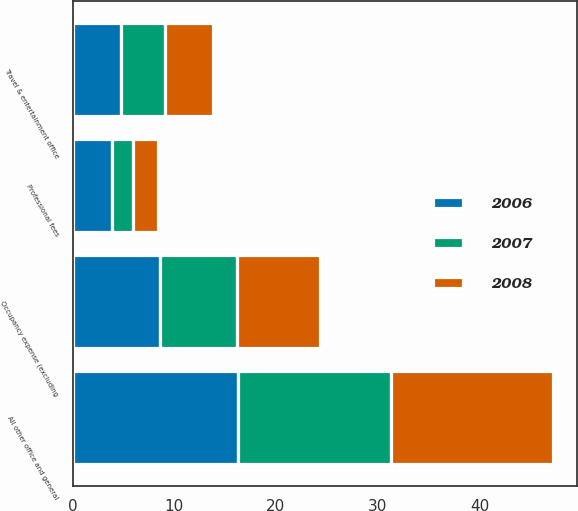<chart> <loc_0><loc_0><loc_500><loc_500><stacked_bar_chart><ecel><fcel>Professional fees<fcel>Occupancy expense (excluding<fcel>Travel & entertainment office<fcel>All other office and general<nl><fcel>2007<fcel>2<fcel>7.6<fcel>4.3<fcel>15<nl><fcel>2008<fcel>2.5<fcel>8.1<fcel>4.7<fcel>15.9<nl><fcel>2006<fcel>3.9<fcel>8.6<fcel>4.8<fcel>16.3<nl></chart> 